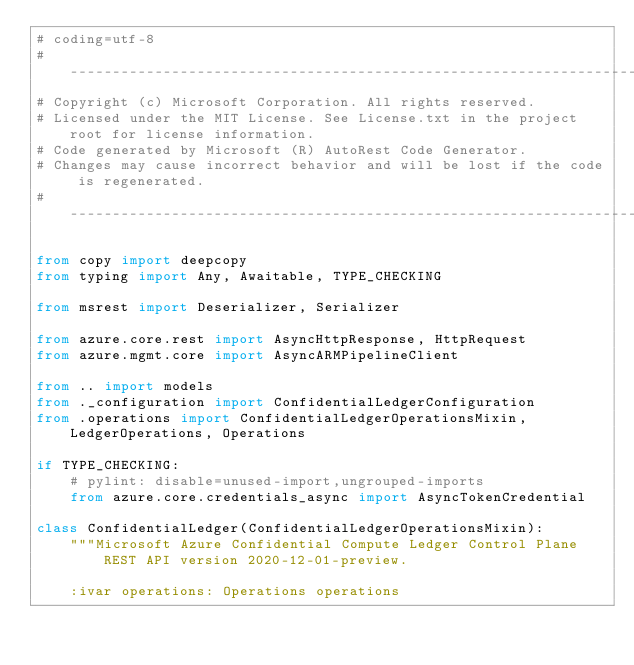<code> <loc_0><loc_0><loc_500><loc_500><_Python_># coding=utf-8
# --------------------------------------------------------------------------
# Copyright (c) Microsoft Corporation. All rights reserved.
# Licensed under the MIT License. See License.txt in the project root for license information.
# Code generated by Microsoft (R) AutoRest Code Generator.
# Changes may cause incorrect behavior and will be lost if the code is regenerated.
# --------------------------------------------------------------------------

from copy import deepcopy
from typing import Any, Awaitable, TYPE_CHECKING

from msrest import Deserializer, Serializer

from azure.core.rest import AsyncHttpResponse, HttpRequest
from azure.mgmt.core import AsyncARMPipelineClient

from .. import models
from ._configuration import ConfidentialLedgerConfiguration
from .operations import ConfidentialLedgerOperationsMixin, LedgerOperations, Operations

if TYPE_CHECKING:
    # pylint: disable=unused-import,ungrouped-imports
    from azure.core.credentials_async import AsyncTokenCredential

class ConfidentialLedger(ConfidentialLedgerOperationsMixin):
    """Microsoft Azure Confidential Compute Ledger Control Plane REST API version 2020-12-01-preview.

    :ivar operations: Operations operations</code> 